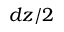<formula> <loc_0><loc_0><loc_500><loc_500>d z / 2</formula> 